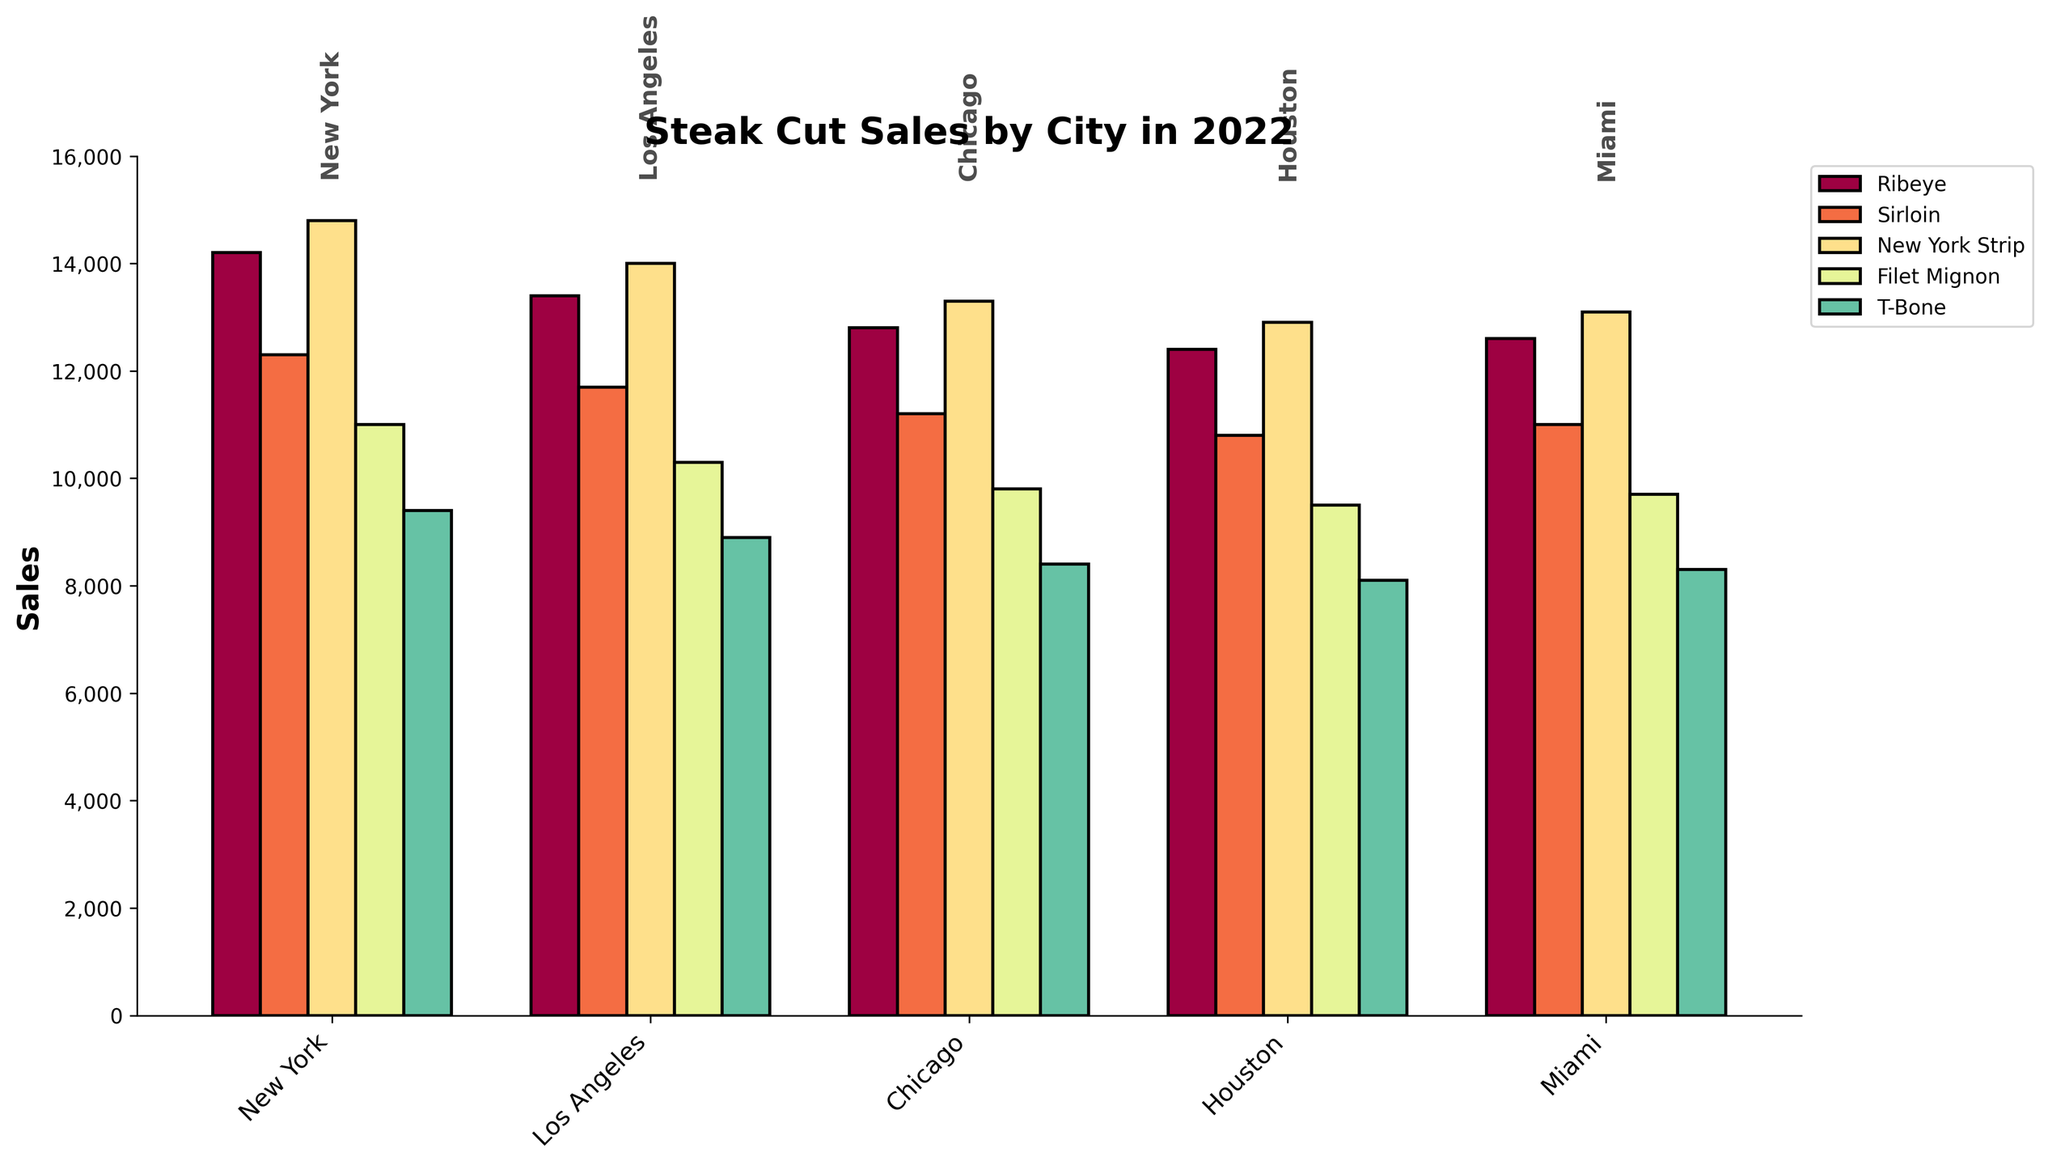How do the sales of Ribeye in New York compare to those in Los Angeles in 2022? The height of the bar for Ribeye sales in 2022 in New York is higher than that of Los Angeles. By checking the respective bars, the sales in New York are 14200 and in Los Angeles are 13400.
Answer: New York has higher sales Which steak cut had the highest sales in Chicago in 2022? By examining the bars for Chicago in 2022, the tallest bar (indicating highest sales) is for New York Strip, which dominates the skyline as compared to the other cuts.
Answer: New York Strip What's the total sales of all steak cuts in Miami in 2022? Add the heights of all bars for Miami in 2022. The sales are Ribeye: 12600, Sirloin: 11000, New York Strip: 13100, Filet Mignon: 9700, and T-Bone: 8300. So, the total is 12600 + 11000 + 13100 + 9700 + 8300 = 54700.
Answer: 54700 Which city had the lowest sales for T-Bone in 2022? By examining the T-Bone bars for 2022, Houston has the lowest bar height compared to other cities.
Answer: Houston Compared to 2021, how much did Filet Mignon sales increase in New York in 2022? The Filet Mignon sales in New York for 2021 are represented by a bar with a height of 10500 and for 2022 it is 11000. The increase can be calculated as 11000 - 10500 = 500.
Answer: 500 Is the sales trend for Sirloin increasing or decreasing from 2018 to 2022 in Los Angeles? By analyzing the height progression of the Sirloin bars from 2018 to 2022, the heights are consistently increasing every year (10500, 10900, 10600, 11200, 11700). This indicates an increasing trend.
Answer: Increasing Which steak cut has the least sales variation across all cities in 2022? By visually comparing the bars for each steak cut across all cities in 2022, Filet Mignon seems to exhibit the least variation in bar heights.
Answer: Filet Mignon What is the difference in total steak sales between New York and Chicago in 2022? Summing the bar heights for New York: 14200 (Ribeye) + 12300 (Sirloin) + 14800 (New York Strip) + 11000 (Filet Mignon) + 9400 (T-Bone) = 61700. For Chicago: 12800 (Ribeye) + 11200 (Sirloin) + 13300 (New York Strip) + 9800 (Filet Mignon) + 8400 (T-Bone) = 55500. The difference is 61700 - 55500 = 6200.
Answer: 6200 Which city had the highest increase in New York Strip sales from 2021 to 2022? By comparing the New York Strip bars’ height difference for each city from 2021 to 2022, New York has the highest increment: from 14200 in 2021 to 14800 in 2022, which is an increase of 600.
Answer: New York 